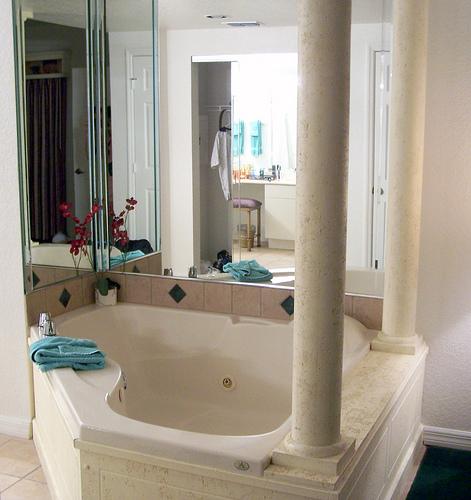Which room is this?
Be succinct. Bathroom. What color is the water in the bathtub?
Answer briefly. Clear. What color is the towel?
Be succinct. Blue. Is the towel wet?
Answer briefly. No. How many tubes are in this room?
Give a very brief answer. 1. 